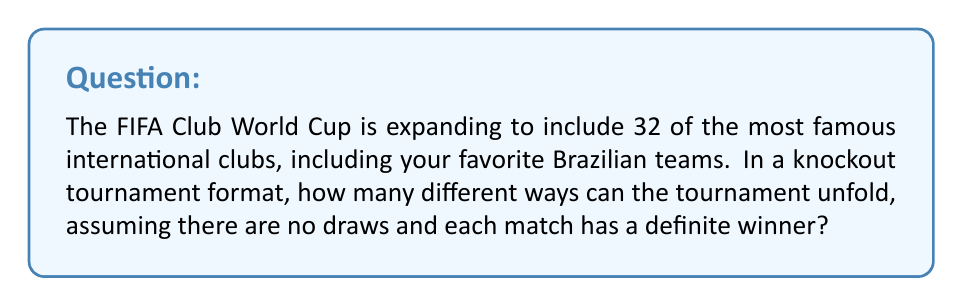Could you help me with this problem? Let's approach this step-by-step:

1) In a knockout tournament with 32 teams, there will be 5 rounds:
   - Round of 32 (16 matches)
   - Round of 16 (8 matches)
   - Quarter-finals (4 matches)
   - Semi-finals (2 matches)
   - Final (1 match)

2) In total, there will be $16 + 8 + 4 + 2 + 1 = 31$ matches.

3) Each match has 2 possible outcomes (either team can win).

4) The number of possible ways the entire tournament can unfold is equal to the number of ways each match can be decided, multiplied together.

5) This can be represented mathematically as:

   $$2^{31}$$

6) This is because we have 2 choices for each of the 31 matches, and we multiply these choices together.

7) Calculating this:
   
   $$2^{31} = 2,147,483,648$$

Therefore, there are 2,147,483,648 different ways the tournament can unfold.
Answer: $$2^{31} = 2,147,483,648$$ 